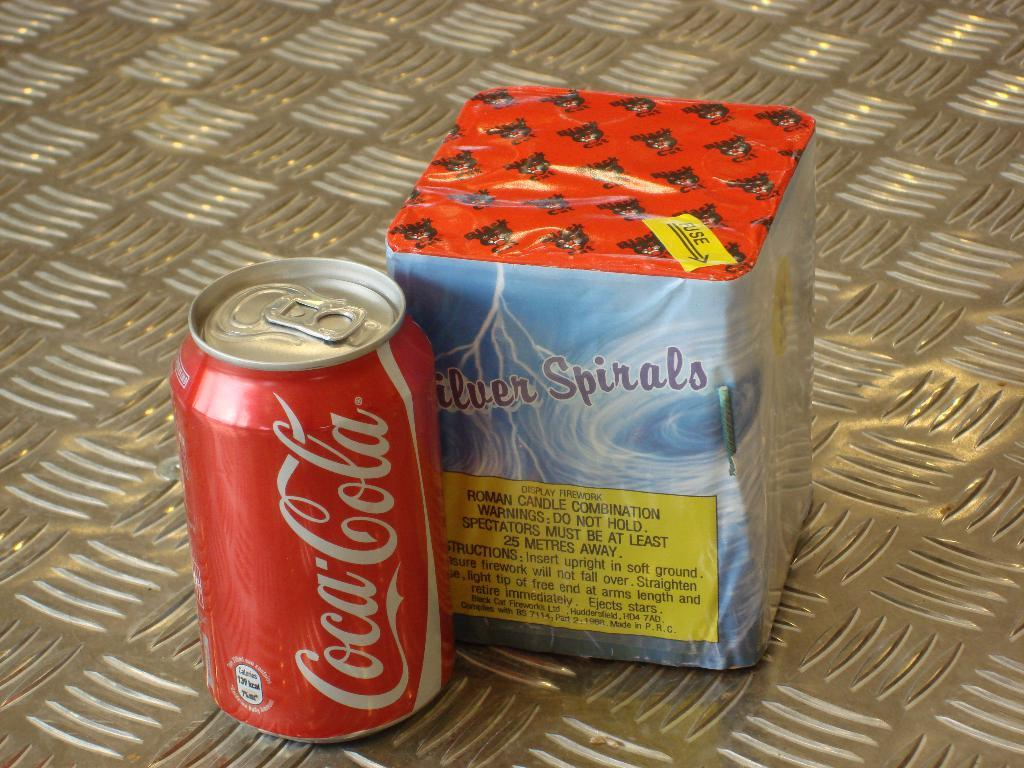Provide a one-sentence caption for the provided image. Coca cola can and some fireworks is sitting beside each other. 